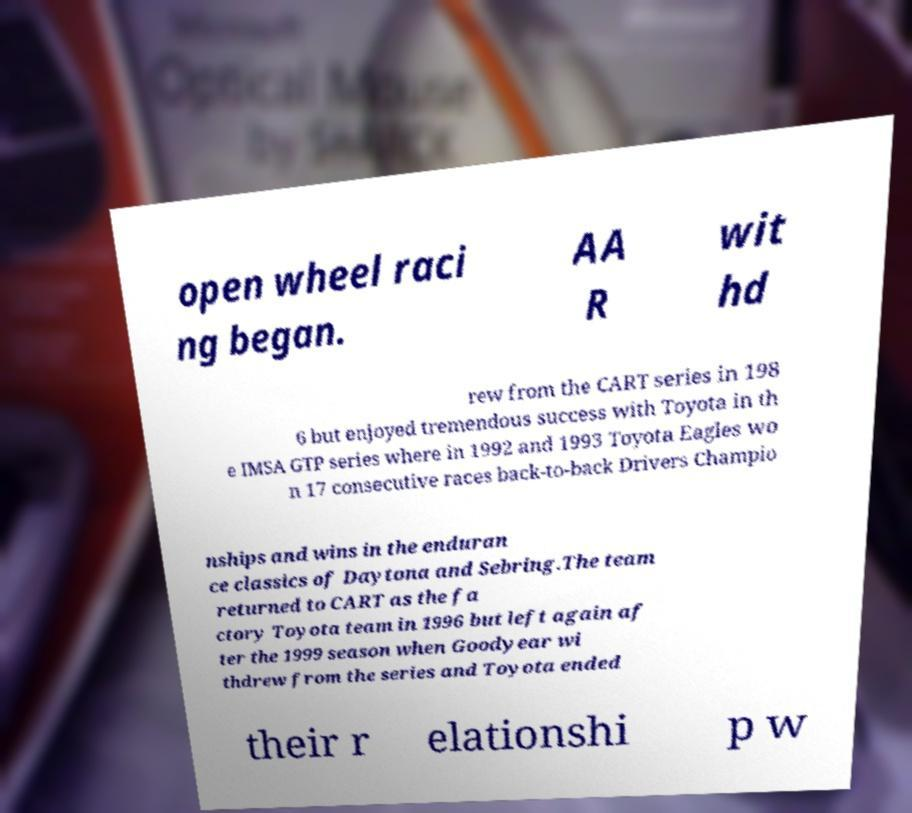Please read and relay the text visible in this image. What does it say? open wheel raci ng began. AA R wit hd rew from the CART series in 198 6 but enjoyed tremendous success with Toyota in th e IMSA GTP series where in 1992 and 1993 Toyota Eagles wo n 17 consecutive races back-to-back Drivers Champio nships and wins in the enduran ce classics of Daytona and Sebring.The team returned to CART as the fa ctory Toyota team in 1996 but left again af ter the 1999 season when Goodyear wi thdrew from the series and Toyota ended their r elationshi p w 